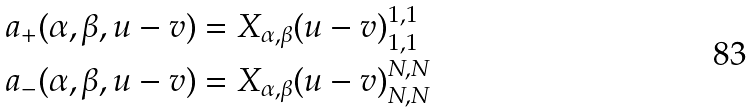<formula> <loc_0><loc_0><loc_500><loc_500>& a _ { + } ( \alpha , \beta , u - v ) = X _ { \alpha , \beta } ( u - v ) ^ { 1 , 1 } _ { 1 , 1 } \\ & a _ { - } ( \alpha , \beta , u - v ) = X _ { \alpha , \beta } ( u - v ) ^ { N , N } _ { N , N }</formula> 